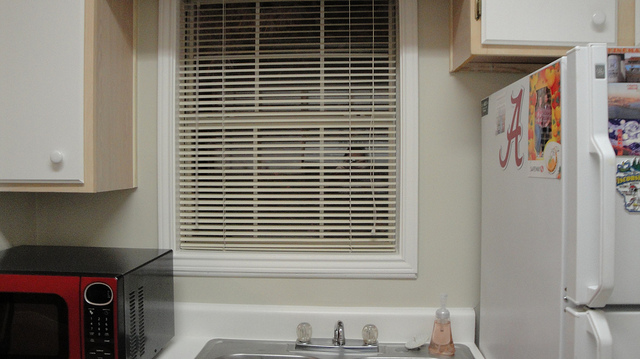<image>Which company makes this refrigerator? It is ambiguous which company makes this refrigerator. It could be Kenmore, Whirlpool, Maytag, Frigidaire, Amana or GE. Which company makes this refrigerator? It is ambiguous which company makes this refrigerator. It can be either Kenmore, Whirlpool, Maytag, Frigidaire, or Amana. 